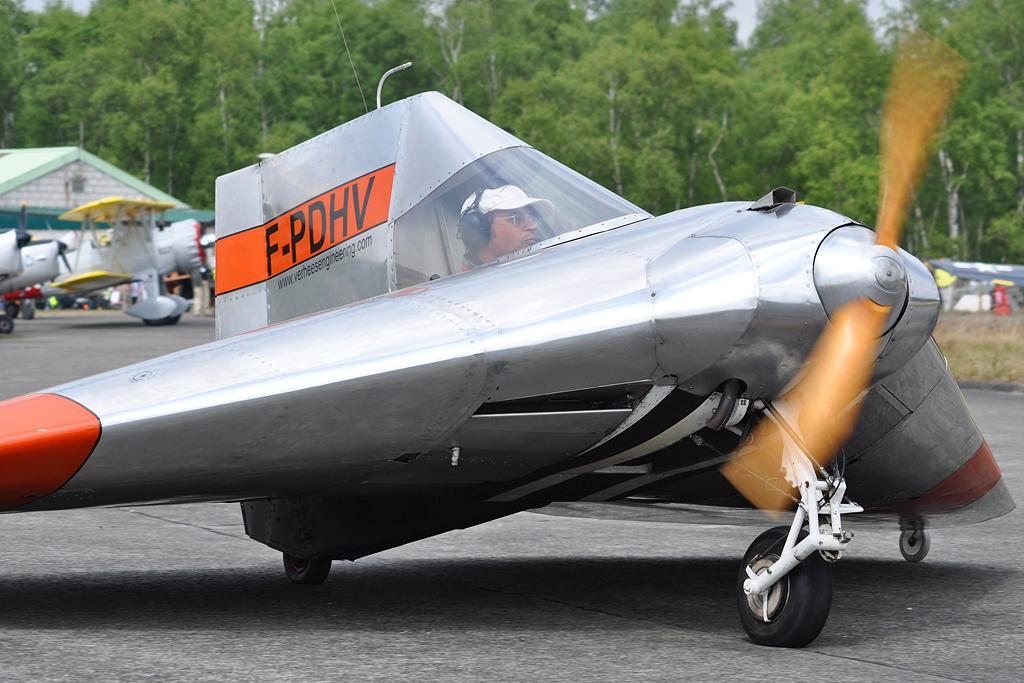<image>
Give a short and clear explanation of the subsequent image. A small airplane with the letters F-PDHV written on it starts its engine 